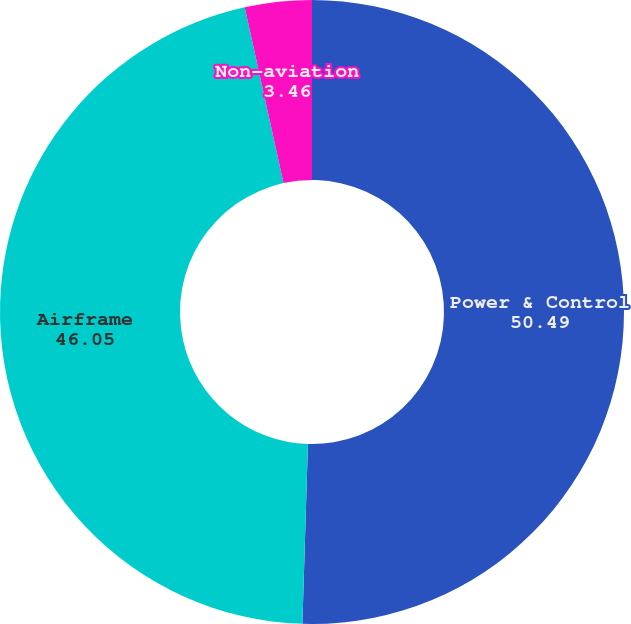<chart> <loc_0><loc_0><loc_500><loc_500><pie_chart><fcel>Power & Control<fcel>Airframe<fcel>Non-aviation<nl><fcel>50.49%<fcel>46.05%<fcel>3.46%<nl></chart> 